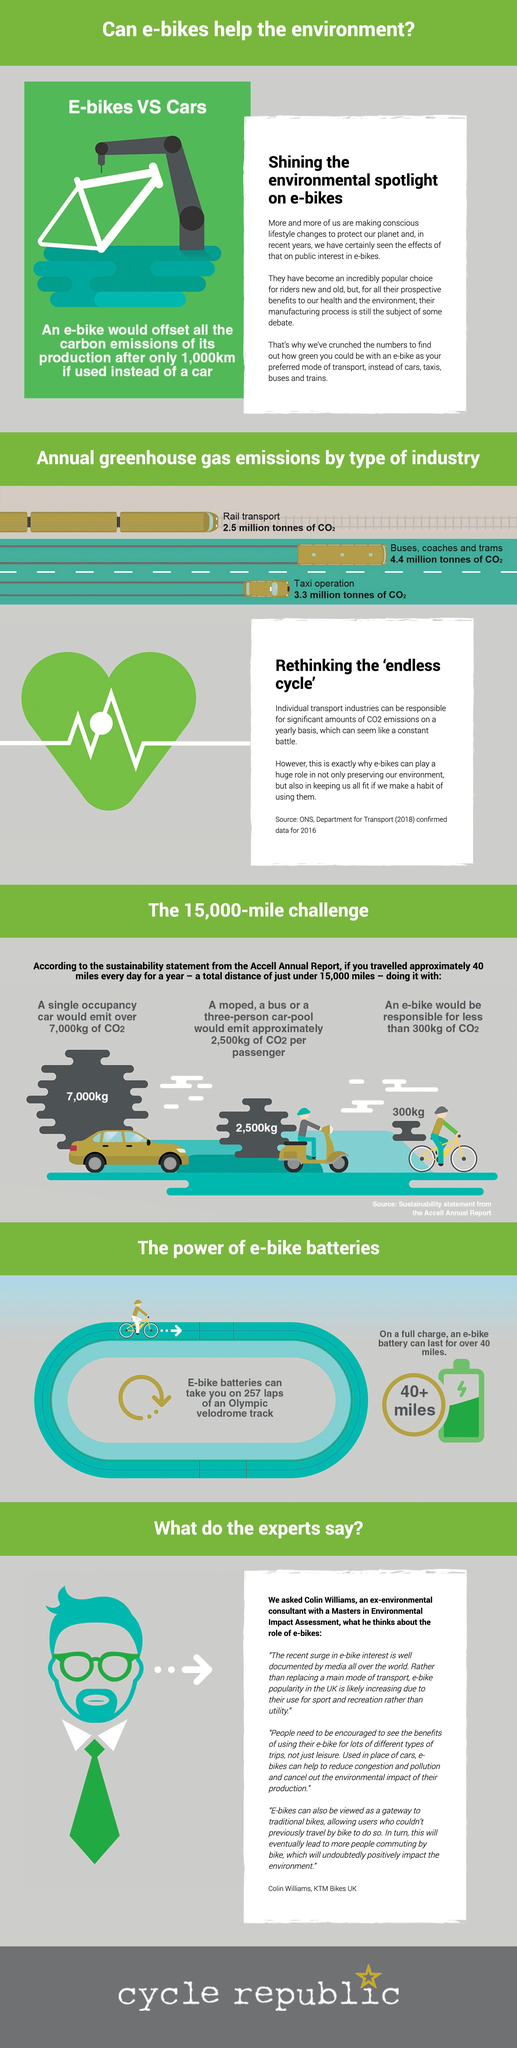Give some essential details in this illustration. Each passenger emits approximately 2,500 kilograms of CO2 when traveling, whether it is a moped, a bus, or a three-person car-pool. The emission of CO2 by a single occupancy car is significantly higher than that of an e-bike, with a difference of approximately 6,700 kg. A half charge e-bike battery would last for over 20 miles. The expert's spectacles are green. The total greenhouse gas emissions from buses, coaches, trams, and taxi operations amount to approximately 7.7 million tonnes of CO2. 